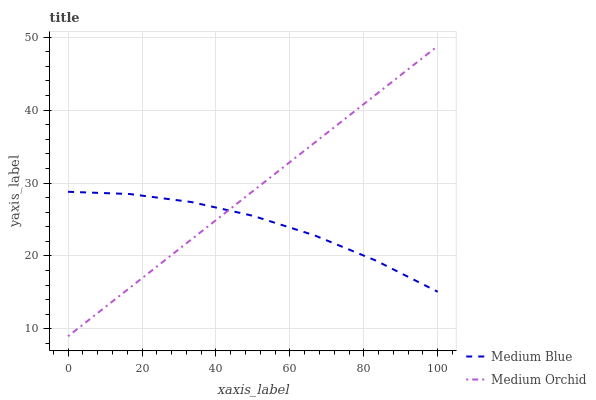Does Medium Blue have the minimum area under the curve?
Answer yes or no. Yes. Does Medium Orchid have the maximum area under the curve?
Answer yes or no. Yes. Does Medium Blue have the maximum area under the curve?
Answer yes or no. No. Is Medium Orchid the smoothest?
Answer yes or no. Yes. Is Medium Blue the roughest?
Answer yes or no. Yes. Is Medium Blue the smoothest?
Answer yes or no. No. Does Medium Orchid have the lowest value?
Answer yes or no. Yes. Does Medium Blue have the lowest value?
Answer yes or no. No. Does Medium Orchid have the highest value?
Answer yes or no. Yes. Does Medium Blue have the highest value?
Answer yes or no. No. Does Medium Blue intersect Medium Orchid?
Answer yes or no. Yes. Is Medium Blue less than Medium Orchid?
Answer yes or no. No. Is Medium Blue greater than Medium Orchid?
Answer yes or no. No. 